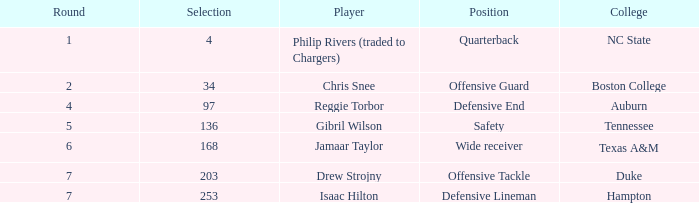In which option is jamaar taylor a player and the round surpasses 6? None. 